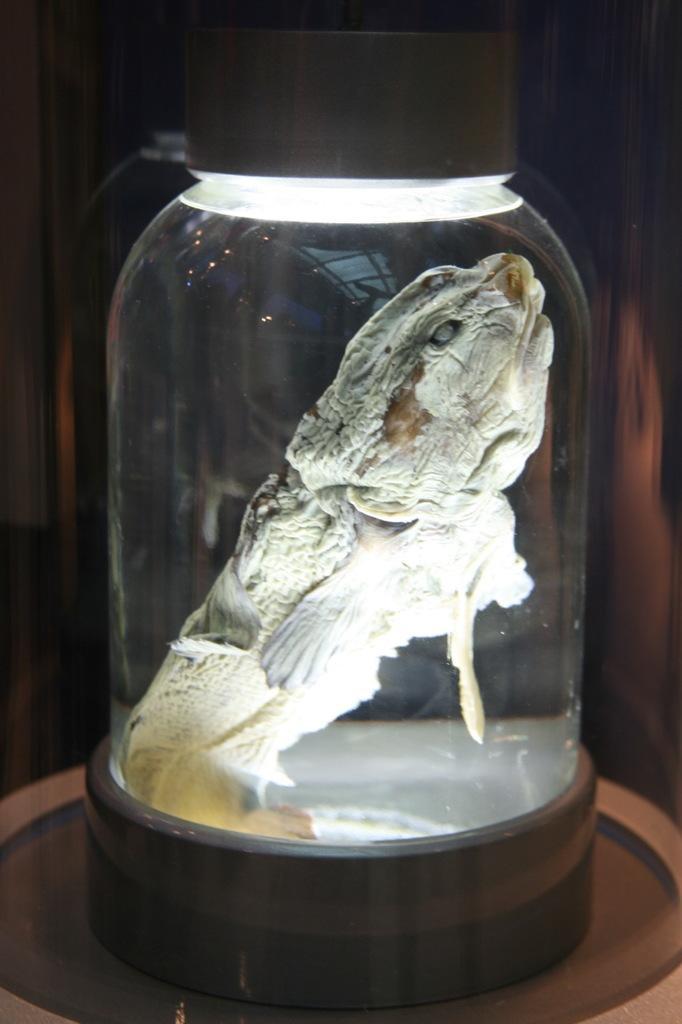In one or two sentences, can you explain what this image depicts? In this image we can see there is a table, on the table there is an animal in the bottle and at the back it looks like a wall. 